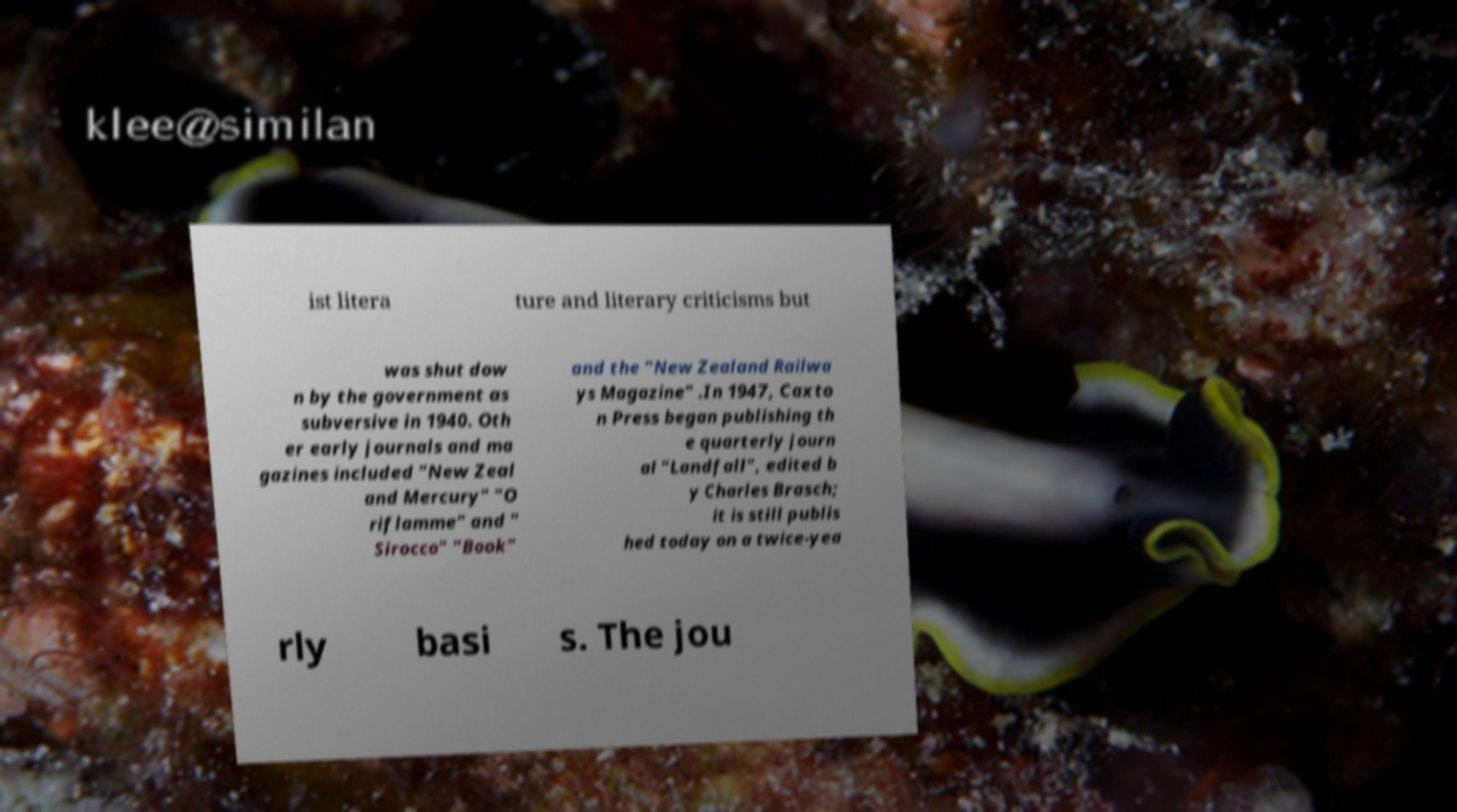Please read and relay the text visible in this image. What does it say? ist litera ture and literary criticisms but was shut dow n by the government as subversive in 1940. Oth er early journals and ma gazines included "New Zeal and Mercury" "O riflamme" and " Sirocco" "Book" and the "New Zealand Railwa ys Magazine" .In 1947, Caxto n Press began publishing th e quarterly journ al "Landfall", edited b y Charles Brasch; it is still publis hed today on a twice-yea rly basi s. The jou 